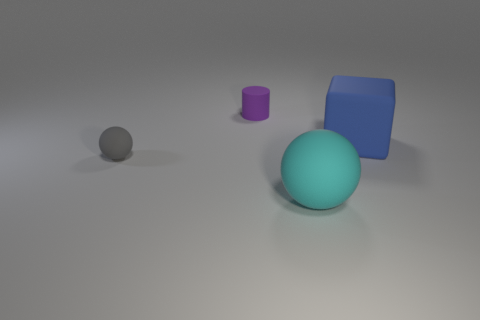Subtract all gray balls. How many balls are left? 1 Add 1 large cyan objects. How many objects exist? 5 Subtract all blocks. How many objects are left? 3 Subtract 1 cylinders. How many cylinders are left? 0 Add 1 cyan spheres. How many cyan spheres are left? 2 Add 1 spheres. How many spheres exist? 3 Subtract 0 brown blocks. How many objects are left? 4 Subtract all red cubes. Subtract all green spheres. How many cubes are left? 1 Subtract all red spheres. How many blue cylinders are left? 0 Subtract all small gray things. Subtract all small matte cylinders. How many objects are left? 2 